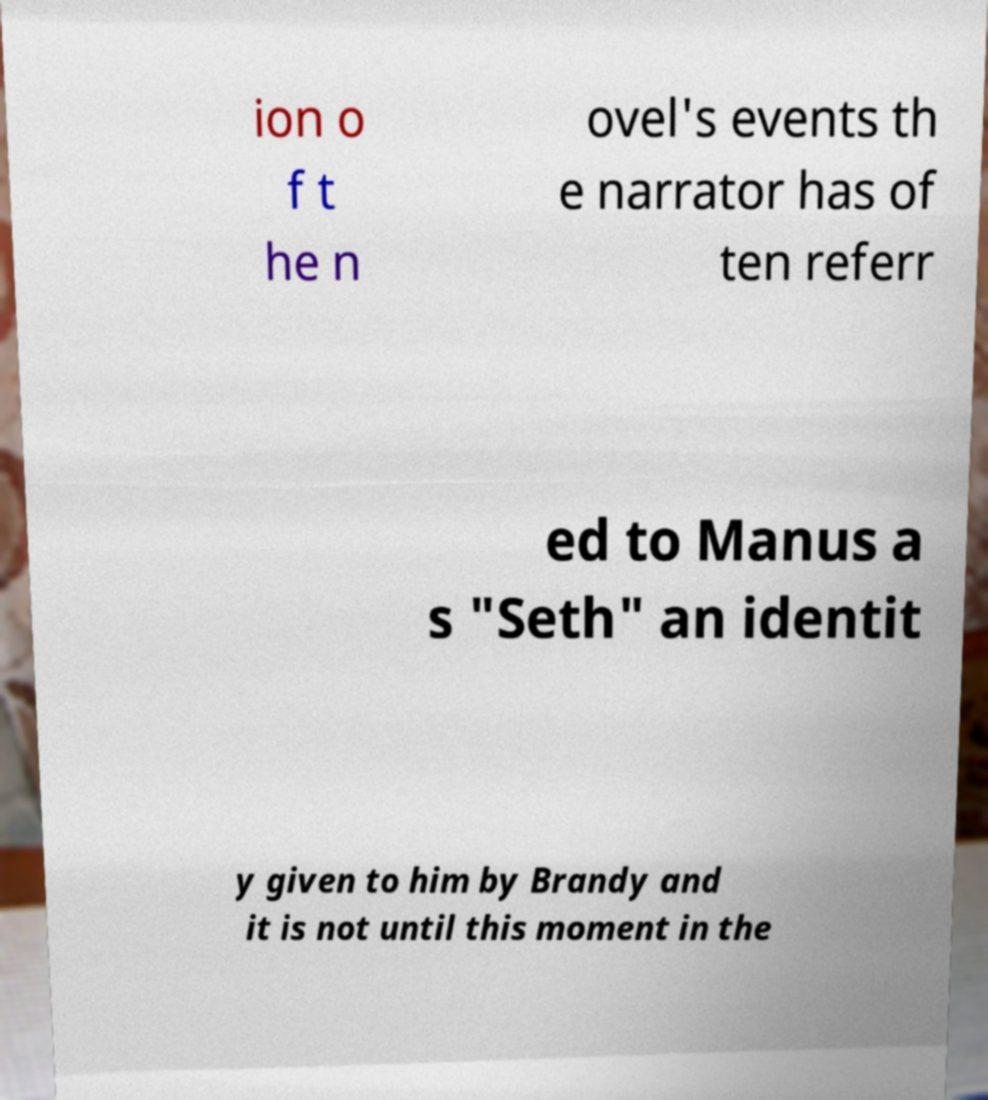Please identify and transcribe the text found in this image. ion o f t he n ovel's events th e narrator has of ten referr ed to Manus a s "Seth" an identit y given to him by Brandy and it is not until this moment in the 